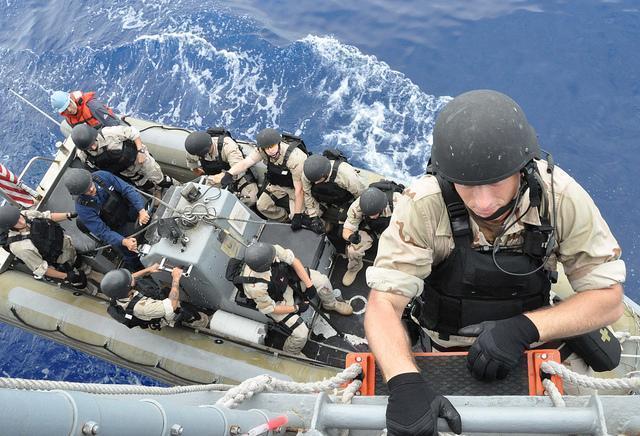How many men are there?
Give a very brief answer. 10. How many people are there?
Give a very brief answer. 10. How many sheep walking in a line in this picture?
Give a very brief answer. 0. 